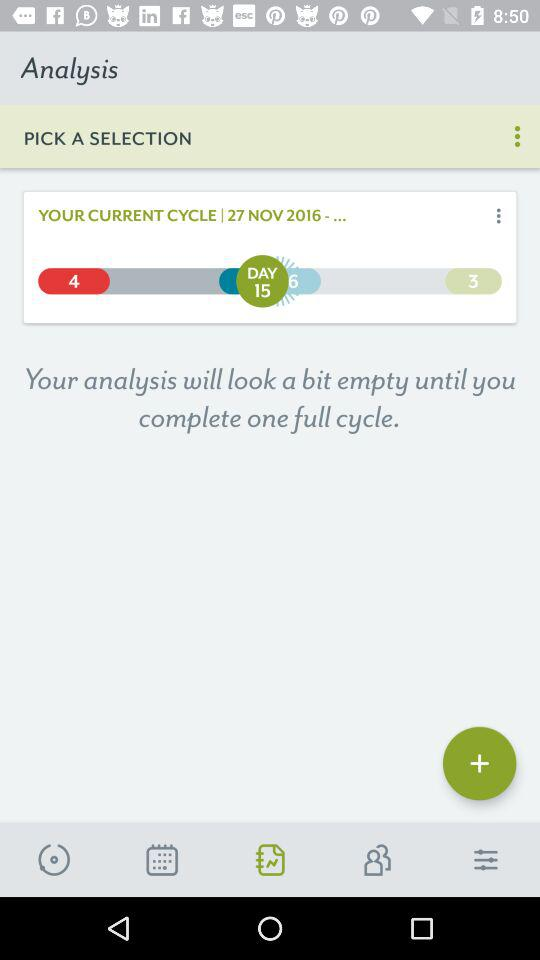What is the selected date? The selected date is November 27, 2016. 